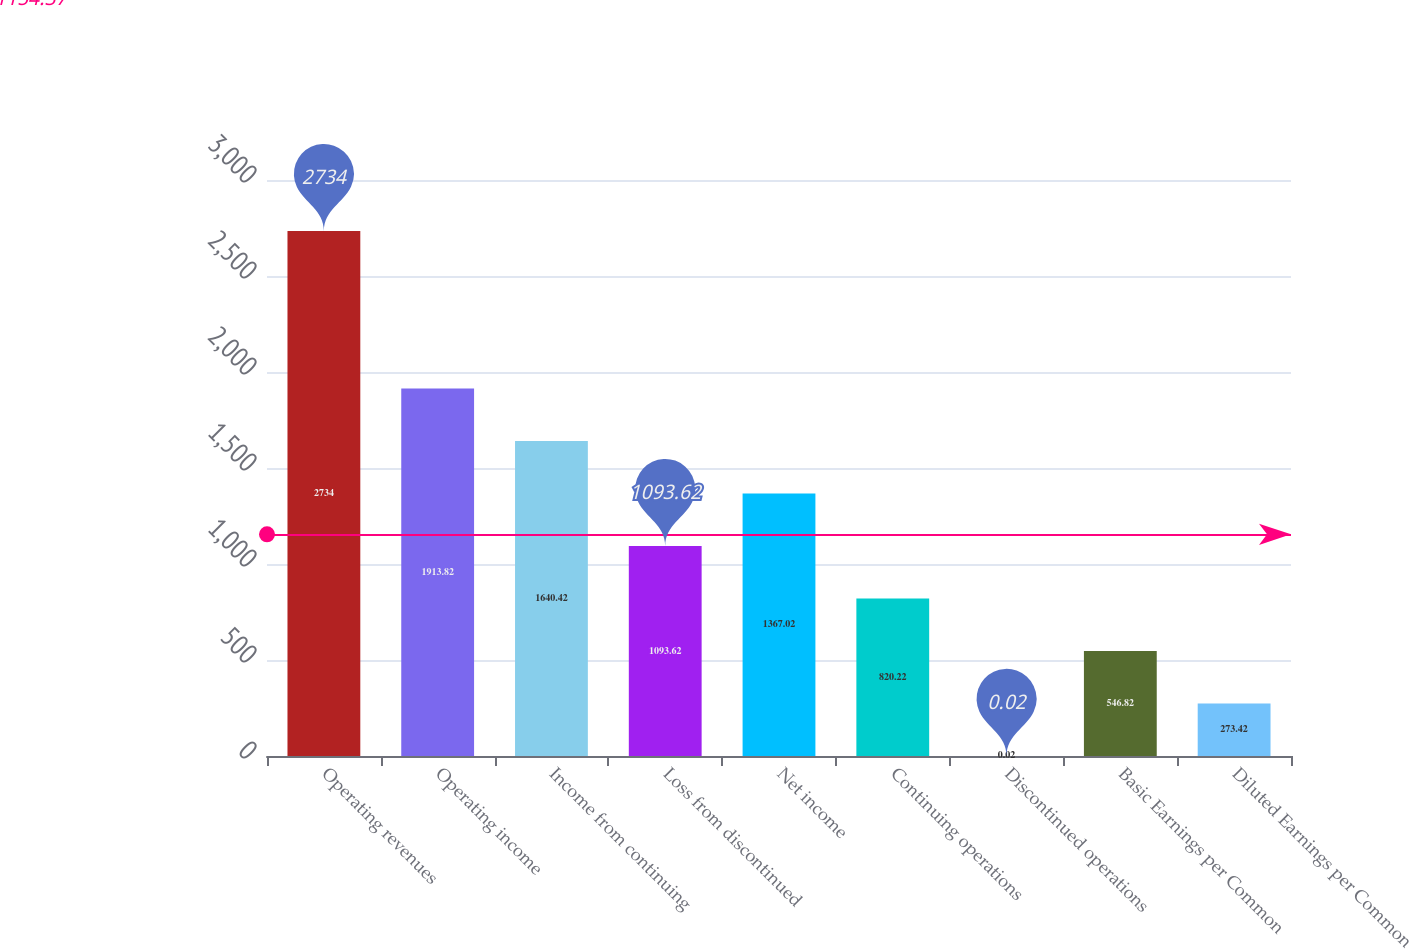Convert chart to OTSL. <chart><loc_0><loc_0><loc_500><loc_500><bar_chart><fcel>Operating revenues<fcel>Operating income<fcel>Income from continuing<fcel>Loss from discontinued<fcel>Net income<fcel>Continuing operations<fcel>Discontinued operations<fcel>Basic Earnings per Common<fcel>Diluted Earnings per Common<nl><fcel>2734<fcel>1913.82<fcel>1640.42<fcel>1093.62<fcel>1367.02<fcel>820.22<fcel>0.02<fcel>546.82<fcel>273.42<nl></chart> 